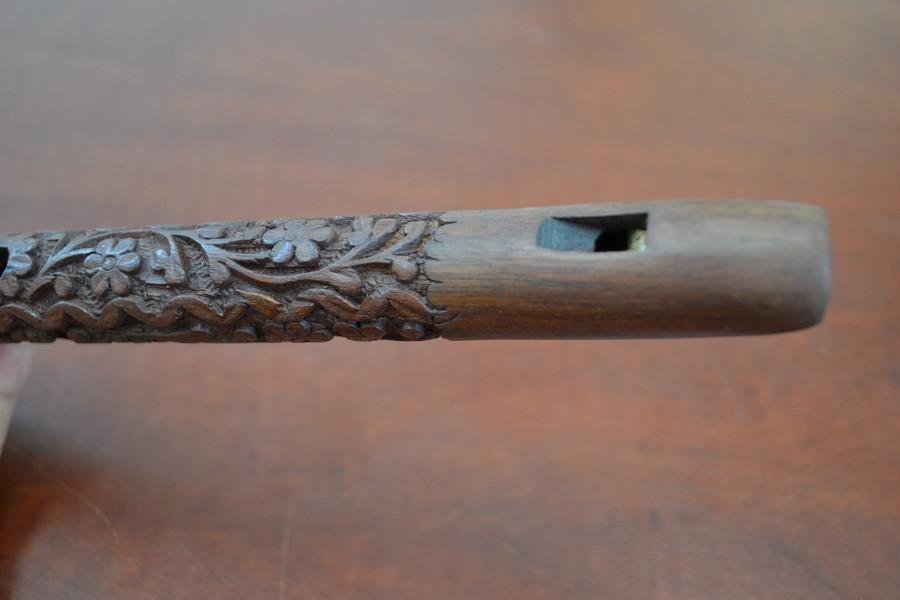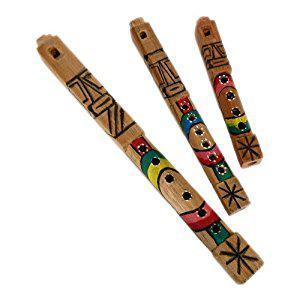The first image is the image on the left, the second image is the image on the right. For the images shown, is this caption "Both flutes are brown and presumably wooden, with little to no decoration." true? Answer yes or no. No. The first image is the image on the left, the second image is the image on the right. Evaluate the accuracy of this statement regarding the images: "There are a total of two flutes facing opposite directions.". Is it true? Answer yes or no. No. 